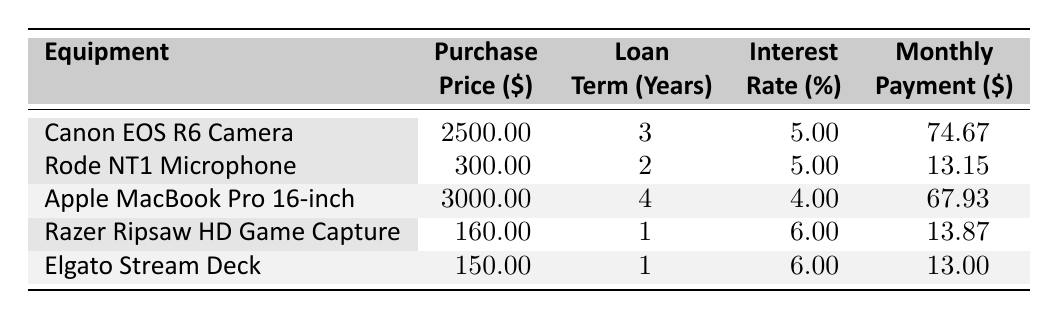What is the loan amount for the Canon EOS R6 Camera? The table shows the loan amount for the Canon EOS R6 Camera under the "Loan" column, which is listed as 3 years alongside its purchase price and interest rate. So, the loan amount is 2500.
Answer: 2500 What is the monthly payment for the Rode NT1 Microphone? From the table, the monthly payment for the Rode NT1 Microphone is found in the "Payment" column, showing a value of 13.15.
Answer: 13.15 Which equipment has the highest monthly payment? To determine this, we can compare all the values in the "Payment" column. The Canon EOS R6 Camera has the highest payment of 74.67, which is higher than all the other equipment listed.
Answer: Canon EOS R6 Camera Is the interest rate for Apple MacBook Pro 16-inch higher than that of Rode NT1 Microphone? Looking at the table, the interest rate for the Apple MacBook Pro is 4% while that for the Rode NT1 Microphone is 5%. Therefore, the statement is false.
Answer: No What is the total purchase price of all listed equipment? We need to sum the purchase prices: 2500 + 300 + 3000 + 160 + 150 = 4910. Thus, the total purchase price is 4910.
Answer: 4910 What is the average monthly payment for all equipment? To find the average, sum the monthly payments: 74.67 + 13.15 + 67.93 + 13.87 + 13.00 = 182.62. Then, divide by the number of items (5): 182.62 / 5 = 36.52. Therefore, the average monthly payment is 36.52.
Answer: 36.52 Does Elgato Stream Deck have the shortest loan term? By comparing the loan terms in the "Term" column of the table, the Elgato Stream Deck has a loan term of 1 year, which is indeed the shortest among the listed items.
Answer: Yes What is the difference in purchase price between the most and least expensive equipment? The most expensive equipment is the Apple MacBook Pro at 3000 and the least expensive is the Razer Ripsaw HD Game Capture at 160. The difference is 3000 - 160 = 2840.
Answer: 2840 What is the combined loan amount for all equipment? The total loan amount can be calculated by summing the loan amounts: 2500 + 300 + 3000 + 160 + 150 = 4910. Therefore, the combined loan amount for all equipment is 4910.
Answer: 4910 